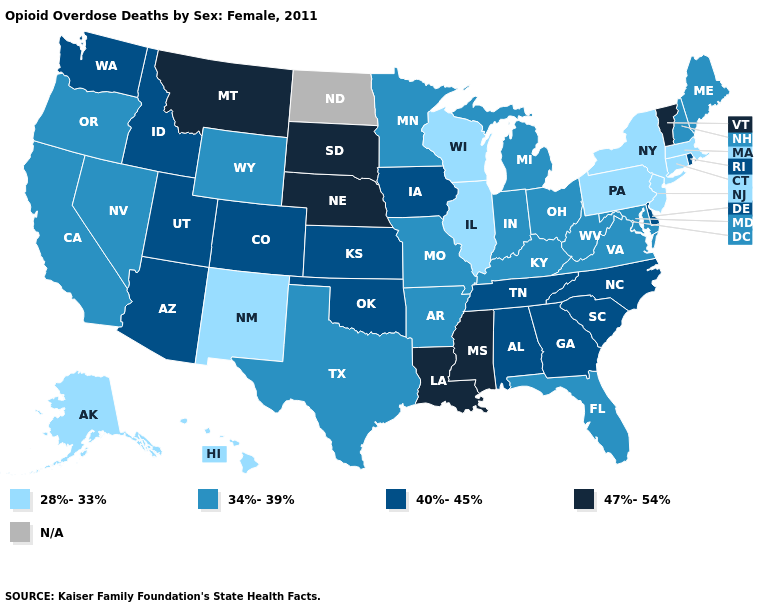What is the value of Utah?
Write a very short answer. 40%-45%. What is the lowest value in states that border Utah?
Be succinct. 28%-33%. Name the states that have a value in the range 34%-39%?
Concise answer only. Arkansas, California, Florida, Indiana, Kentucky, Maine, Maryland, Michigan, Minnesota, Missouri, Nevada, New Hampshire, Ohio, Oregon, Texas, Virginia, West Virginia, Wyoming. Name the states that have a value in the range 28%-33%?
Answer briefly. Alaska, Connecticut, Hawaii, Illinois, Massachusetts, New Jersey, New Mexico, New York, Pennsylvania, Wisconsin. Name the states that have a value in the range 34%-39%?
Give a very brief answer. Arkansas, California, Florida, Indiana, Kentucky, Maine, Maryland, Michigan, Minnesota, Missouri, Nevada, New Hampshire, Ohio, Oregon, Texas, Virginia, West Virginia, Wyoming. Name the states that have a value in the range 40%-45%?
Be succinct. Alabama, Arizona, Colorado, Delaware, Georgia, Idaho, Iowa, Kansas, North Carolina, Oklahoma, Rhode Island, South Carolina, Tennessee, Utah, Washington. Name the states that have a value in the range 28%-33%?
Write a very short answer. Alaska, Connecticut, Hawaii, Illinois, Massachusetts, New Jersey, New Mexico, New York, Pennsylvania, Wisconsin. Among the states that border Connecticut , which have the highest value?
Give a very brief answer. Rhode Island. Which states hav the highest value in the MidWest?
Short answer required. Nebraska, South Dakota. What is the value of Florida?
Give a very brief answer. 34%-39%. Name the states that have a value in the range 47%-54%?
Be succinct. Louisiana, Mississippi, Montana, Nebraska, South Dakota, Vermont. What is the value of Massachusetts?
Keep it brief. 28%-33%. Among the states that border New Jersey , which have the lowest value?
Write a very short answer. New York, Pennsylvania. 